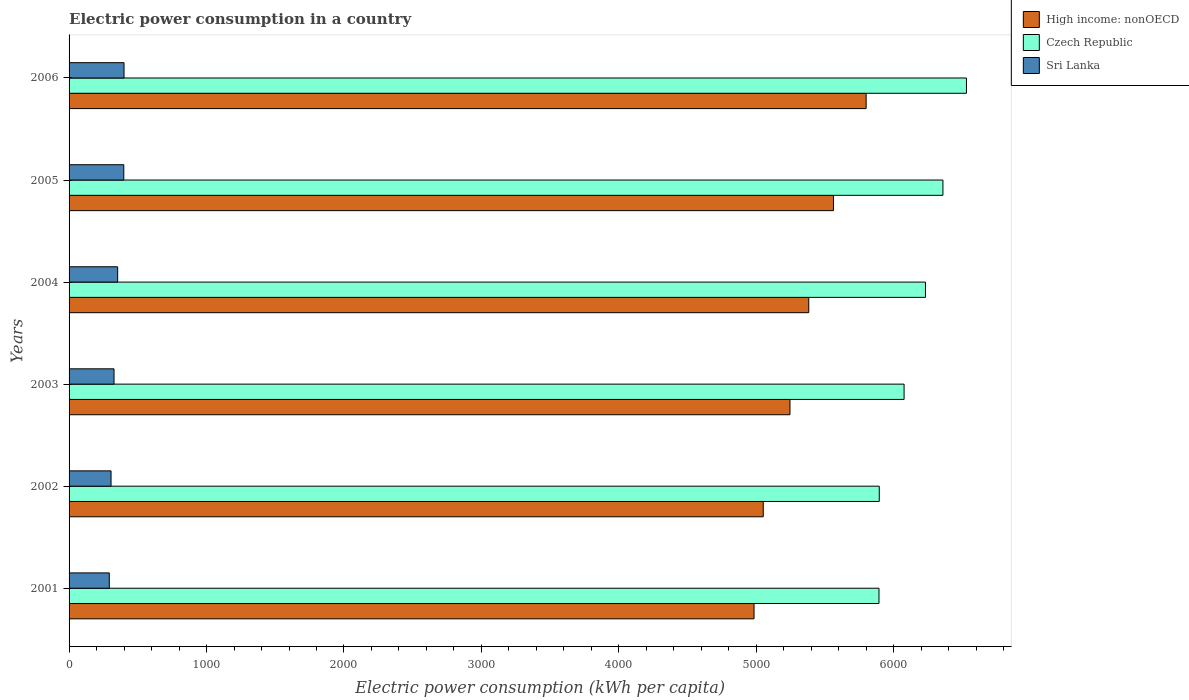How many different coloured bars are there?
Make the answer very short. 3. Are the number of bars per tick equal to the number of legend labels?
Your answer should be compact. Yes. Are the number of bars on each tick of the Y-axis equal?
Give a very brief answer. Yes. How many bars are there on the 5th tick from the bottom?
Your response must be concise. 3. In how many cases, is the number of bars for a given year not equal to the number of legend labels?
Your answer should be very brief. 0. What is the electric power consumption in in Sri Lanka in 2001?
Keep it short and to the point. 292.6. Across all years, what is the maximum electric power consumption in in High income: nonOECD?
Your answer should be compact. 5798.77. Across all years, what is the minimum electric power consumption in in High income: nonOECD?
Your answer should be very brief. 4983.16. In which year was the electric power consumption in in Sri Lanka maximum?
Your response must be concise. 2006. In which year was the electric power consumption in in Czech Republic minimum?
Offer a very short reply. 2001. What is the total electric power consumption in in Czech Republic in the graph?
Provide a short and direct response. 3.70e+04. What is the difference between the electric power consumption in in High income: nonOECD in 2001 and that in 2005?
Your response must be concise. -577.9. What is the difference between the electric power consumption in in Czech Republic in 2006 and the electric power consumption in in Sri Lanka in 2005?
Provide a short and direct response. 6130.44. What is the average electric power consumption in in High income: nonOECD per year?
Offer a very short reply. 5336.52. In the year 2002, what is the difference between the electric power consumption in in High income: nonOECD and electric power consumption in in Sri Lanka?
Make the answer very short. 4744.83. What is the ratio of the electric power consumption in in Czech Republic in 2003 to that in 2006?
Ensure brevity in your answer.  0.93. What is the difference between the highest and the second highest electric power consumption in in Sri Lanka?
Provide a succinct answer. 1.7. What is the difference between the highest and the lowest electric power consumption in in High income: nonOECD?
Provide a short and direct response. 815.62. What does the 1st bar from the top in 2002 represents?
Give a very brief answer. Sri Lanka. What does the 2nd bar from the bottom in 2005 represents?
Offer a very short reply. Czech Republic. Is it the case that in every year, the sum of the electric power consumption in in Sri Lanka and electric power consumption in in High income: nonOECD is greater than the electric power consumption in in Czech Republic?
Your response must be concise. No. How many bars are there?
Provide a short and direct response. 18. Does the graph contain grids?
Provide a short and direct response. No. What is the title of the graph?
Offer a terse response. Electric power consumption in a country. Does "Italy" appear as one of the legend labels in the graph?
Provide a short and direct response. No. What is the label or title of the X-axis?
Offer a terse response. Electric power consumption (kWh per capita). What is the Electric power consumption (kWh per capita) in High income: nonOECD in 2001?
Provide a succinct answer. 4983.16. What is the Electric power consumption (kWh per capita) of Czech Republic in 2001?
Your response must be concise. 5892.17. What is the Electric power consumption (kWh per capita) of Sri Lanka in 2001?
Offer a terse response. 292.6. What is the Electric power consumption (kWh per capita) in High income: nonOECD in 2002?
Give a very brief answer. 5050.21. What is the Electric power consumption (kWh per capita) in Czech Republic in 2002?
Your response must be concise. 5894.23. What is the Electric power consumption (kWh per capita) in Sri Lanka in 2002?
Your answer should be very brief. 305.37. What is the Electric power consumption (kWh per capita) in High income: nonOECD in 2003?
Offer a terse response. 5244.64. What is the Electric power consumption (kWh per capita) of Czech Republic in 2003?
Ensure brevity in your answer.  6074.85. What is the Electric power consumption (kWh per capita) of Sri Lanka in 2003?
Give a very brief answer. 327.13. What is the Electric power consumption (kWh per capita) of High income: nonOECD in 2004?
Keep it short and to the point. 5381.27. What is the Electric power consumption (kWh per capita) of Czech Republic in 2004?
Your response must be concise. 6230.4. What is the Electric power consumption (kWh per capita) of Sri Lanka in 2004?
Offer a terse response. 353.49. What is the Electric power consumption (kWh per capita) of High income: nonOECD in 2005?
Give a very brief answer. 5561.05. What is the Electric power consumption (kWh per capita) in Czech Republic in 2005?
Provide a succinct answer. 6357.42. What is the Electric power consumption (kWh per capita) of Sri Lanka in 2005?
Keep it short and to the point. 398.09. What is the Electric power consumption (kWh per capita) of High income: nonOECD in 2006?
Your answer should be very brief. 5798.77. What is the Electric power consumption (kWh per capita) of Czech Republic in 2006?
Your answer should be compact. 6528.53. What is the Electric power consumption (kWh per capita) in Sri Lanka in 2006?
Provide a succinct answer. 399.79. Across all years, what is the maximum Electric power consumption (kWh per capita) in High income: nonOECD?
Keep it short and to the point. 5798.77. Across all years, what is the maximum Electric power consumption (kWh per capita) of Czech Republic?
Your answer should be compact. 6528.53. Across all years, what is the maximum Electric power consumption (kWh per capita) of Sri Lanka?
Keep it short and to the point. 399.79. Across all years, what is the minimum Electric power consumption (kWh per capita) in High income: nonOECD?
Give a very brief answer. 4983.16. Across all years, what is the minimum Electric power consumption (kWh per capita) of Czech Republic?
Your answer should be compact. 5892.17. Across all years, what is the minimum Electric power consumption (kWh per capita) of Sri Lanka?
Your response must be concise. 292.6. What is the total Electric power consumption (kWh per capita) in High income: nonOECD in the graph?
Ensure brevity in your answer.  3.20e+04. What is the total Electric power consumption (kWh per capita) of Czech Republic in the graph?
Keep it short and to the point. 3.70e+04. What is the total Electric power consumption (kWh per capita) in Sri Lanka in the graph?
Offer a terse response. 2076.46. What is the difference between the Electric power consumption (kWh per capita) of High income: nonOECD in 2001 and that in 2002?
Provide a short and direct response. -67.05. What is the difference between the Electric power consumption (kWh per capita) of Czech Republic in 2001 and that in 2002?
Your answer should be very brief. -2.06. What is the difference between the Electric power consumption (kWh per capita) in Sri Lanka in 2001 and that in 2002?
Offer a terse response. -12.78. What is the difference between the Electric power consumption (kWh per capita) of High income: nonOECD in 2001 and that in 2003?
Your answer should be compact. -261.49. What is the difference between the Electric power consumption (kWh per capita) in Czech Republic in 2001 and that in 2003?
Offer a very short reply. -182.68. What is the difference between the Electric power consumption (kWh per capita) of Sri Lanka in 2001 and that in 2003?
Give a very brief answer. -34.53. What is the difference between the Electric power consumption (kWh per capita) in High income: nonOECD in 2001 and that in 2004?
Offer a terse response. -398.11. What is the difference between the Electric power consumption (kWh per capita) of Czech Republic in 2001 and that in 2004?
Keep it short and to the point. -338.23. What is the difference between the Electric power consumption (kWh per capita) in Sri Lanka in 2001 and that in 2004?
Provide a succinct answer. -60.89. What is the difference between the Electric power consumption (kWh per capita) in High income: nonOECD in 2001 and that in 2005?
Offer a very short reply. -577.9. What is the difference between the Electric power consumption (kWh per capita) in Czech Republic in 2001 and that in 2005?
Your answer should be very brief. -465.25. What is the difference between the Electric power consumption (kWh per capita) in Sri Lanka in 2001 and that in 2005?
Your response must be concise. -105.49. What is the difference between the Electric power consumption (kWh per capita) in High income: nonOECD in 2001 and that in 2006?
Give a very brief answer. -815.62. What is the difference between the Electric power consumption (kWh per capita) in Czech Republic in 2001 and that in 2006?
Your answer should be very brief. -636.36. What is the difference between the Electric power consumption (kWh per capita) in Sri Lanka in 2001 and that in 2006?
Your response must be concise. -107.19. What is the difference between the Electric power consumption (kWh per capita) in High income: nonOECD in 2002 and that in 2003?
Give a very brief answer. -194.44. What is the difference between the Electric power consumption (kWh per capita) of Czech Republic in 2002 and that in 2003?
Keep it short and to the point. -180.62. What is the difference between the Electric power consumption (kWh per capita) in Sri Lanka in 2002 and that in 2003?
Your answer should be compact. -21.75. What is the difference between the Electric power consumption (kWh per capita) of High income: nonOECD in 2002 and that in 2004?
Your response must be concise. -331.06. What is the difference between the Electric power consumption (kWh per capita) in Czech Republic in 2002 and that in 2004?
Your response must be concise. -336.17. What is the difference between the Electric power consumption (kWh per capita) in Sri Lanka in 2002 and that in 2004?
Your response must be concise. -48.11. What is the difference between the Electric power consumption (kWh per capita) in High income: nonOECD in 2002 and that in 2005?
Your answer should be very brief. -510.85. What is the difference between the Electric power consumption (kWh per capita) in Czech Republic in 2002 and that in 2005?
Offer a terse response. -463.19. What is the difference between the Electric power consumption (kWh per capita) of Sri Lanka in 2002 and that in 2005?
Your answer should be compact. -92.71. What is the difference between the Electric power consumption (kWh per capita) of High income: nonOECD in 2002 and that in 2006?
Offer a very short reply. -748.57. What is the difference between the Electric power consumption (kWh per capita) of Czech Republic in 2002 and that in 2006?
Your response must be concise. -634.3. What is the difference between the Electric power consumption (kWh per capita) of Sri Lanka in 2002 and that in 2006?
Make the answer very short. -94.41. What is the difference between the Electric power consumption (kWh per capita) in High income: nonOECD in 2003 and that in 2004?
Your response must be concise. -136.63. What is the difference between the Electric power consumption (kWh per capita) of Czech Republic in 2003 and that in 2004?
Ensure brevity in your answer.  -155.55. What is the difference between the Electric power consumption (kWh per capita) in Sri Lanka in 2003 and that in 2004?
Provide a succinct answer. -26.36. What is the difference between the Electric power consumption (kWh per capita) of High income: nonOECD in 2003 and that in 2005?
Your response must be concise. -316.41. What is the difference between the Electric power consumption (kWh per capita) in Czech Republic in 2003 and that in 2005?
Your answer should be compact. -282.57. What is the difference between the Electric power consumption (kWh per capita) of Sri Lanka in 2003 and that in 2005?
Give a very brief answer. -70.96. What is the difference between the Electric power consumption (kWh per capita) in High income: nonOECD in 2003 and that in 2006?
Ensure brevity in your answer.  -554.13. What is the difference between the Electric power consumption (kWh per capita) of Czech Republic in 2003 and that in 2006?
Your response must be concise. -453.68. What is the difference between the Electric power consumption (kWh per capita) of Sri Lanka in 2003 and that in 2006?
Give a very brief answer. -72.66. What is the difference between the Electric power consumption (kWh per capita) in High income: nonOECD in 2004 and that in 2005?
Give a very brief answer. -179.78. What is the difference between the Electric power consumption (kWh per capita) in Czech Republic in 2004 and that in 2005?
Ensure brevity in your answer.  -127.02. What is the difference between the Electric power consumption (kWh per capita) of Sri Lanka in 2004 and that in 2005?
Offer a terse response. -44.6. What is the difference between the Electric power consumption (kWh per capita) in High income: nonOECD in 2004 and that in 2006?
Provide a succinct answer. -417.5. What is the difference between the Electric power consumption (kWh per capita) in Czech Republic in 2004 and that in 2006?
Offer a very short reply. -298.13. What is the difference between the Electric power consumption (kWh per capita) in Sri Lanka in 2004 and that in 2006?
Keep it short and to the point. -46.3. What is the difference between the Electric power consumption (kWh per capita) of High income: nonOECD in 2005 and that in 2006?
Provide a short and direct response. -237.72. What is the difference between the Electric power consumption (kWh per capita) in Czech Republic in 2005 and that in 2006?
Your response must be concise. -171.11. What is the difference between the Electric power consumption (kWh per capita) of Sri Lanka in 2005 and that in 2006?
Make the answer very short. -1.7. What is the difference between the Electric power consumption (kWh per capita) of High income: nonOECD in 2001 and the Electric power consumption (kWh per capita) of Czech Republic in 2002?
Your answer should be compact. -911.08. What is the difference between the Electric power consumption (kWh per capita) in High income: nonOECD in 2001 and the Electric power consumption (kWh per capita) in Sri Lanka in 2002?
Ensure brevity in your answer.  4677.78. What is the difference between the Electric power consumption (kWh per capita) of Czech Republic in 2001 and the Electric power consumption (kWh per capita) of Sri Lanka in 2002?
Provide a succinct answer. 5586.8. What is the difference between the Electric power consumption (kWh per capita) of High income: nonOECD in 2001 and the Electric power consumption (kWh per capita) of Czech Republic in 2003?
Provide a succinct answer. -1091.69. What is the difference between the Electric power consumption (kWh per capita) of High income: nonOECD in 2001 and the Electric power consumption (kWh per capita) of Sri Lanka in 2003?
Your answer should be compact. 4656.03. What is the difference between the Electric power consumption (kWh per capita) in Czech Republic in 2001 and the Electric power consumption (kWh per capita) in Sri Lanka in 2003?
Ensure brevity in your answer.  5565.05. What is the difference between the Electric power consumption (kWh per capita) of High income: nonOECD in 2001 and the Electric power consumption (kWh per capita) of Czech Republic in 2004?
Give a very brief answer. -1247.24. What is the difference between the Electric power consumption (kWh per capita) of High income: nonOECD in 2001 and the Electric power consumption (kWh per capita) of Sri Lanka in 2004?
Your answer should be compact. 4629.67. What is the difference between the Electric power consumption (kWh per capita) in Czech Republic in 2001 and the Electric power consumption (kWh per capita) in Sri Lanka in 2004?
Provide a short and direct response. 5538.69. What is the difference between the Electric power consumption (kWh per capita) in High income: nonOECD in 2001 and the Electric power consumption (kWh per capita) in Czech Republic in 2005?
Offer a terse response. -1374.27. What is the difference between the Electric power consumption (kWh per capita) of High income: nonOECD in 2001 and the Electric power consumption (kWh per capita) of Sri Lanka in 2005?
Offer a very short reply. 4585.07. What is the difference between the Electric power consumption (kWh per capita) of Czech Republic in 2001 and the Electric power consumption (kWh per capita) of Sri Lanka in 2005?
Ensure brevity in your answer.  5494.09. What is the difference between the Electric power consumption (kWh per capita) of High income: nonOECD in 2001 and the Electric power consumption (kWh per capita) of Czech Republic in 2006?
Make the answer very short. -1545.37. What is the difference between the Electric power consumption (kWh per capita) of High income: nonOECD in 2001 and the Electric power consumption (kWh per capita) of Sri Lanka in 2006?
Your response must be concise. 4583.37. What is the difference between the Electric power consumption (kWh per capita) of Czech Republic in 2001 and the Electric power consumption (kWh per capita) of Sri Lanka in 2006?
Ensure brevity in your answer.  5492.38. What is the difference between the Electric power consumption (kWh per capita) in High income: nonOECD in 2002 and the Electric power consumption (kWh per capita) in Czech Republic in 2003?
Ensure brevity in your answer.  -1024.64. What is the difference between the Electric power consumption (kWh per capita) of High income: nonOECD in 2002 and the Electric power consumption (kWh per capita) of Sri Lanka in 2003?
Ensure brevity in your answer.  4723.08. What is the difference between the Electric power consumption (kWh per capita) of Czech Republic in 2002 and the Electric power consumption (kWh per capita) of Sri Lanka in 2003?
Keep it short and to the point. 5567.11. What is the difference between the Electric power consumption (kWh per capita) in High income: nonOECD in 2002 and the Electric power consumption (kWh per capita) in Czech Republic in 2004?
Make the answer very short. -1180.19. What is the difference between the Electric power consumption (kWh per capita) of High income: nonOECD in 2002 and the Electric power consumption (kWh per capita) of Sri Lanka in 2004?
Ensure brevity in your answer.  4696.72. What is the difference between the Electric power consumption (kWh per capita) in Czech Republic in 2002 and the Electric power consumption (kWh per capita) in Sri Lanka in 2004?
Ensure brevity in your answer.  5540.75. What is the difference between the Electric power consumption (kWh per capita) of High income: nonOECD in 2002 and the Electric power consumption (kWh per capita) of Czech Republic in 2005?
Ensure brevity in your answer.  -1307.21. What is the difference between the Electric power consumption (kWh per capita) of High income: nonOECD in 2002 and the Electric power consumption (kWh per capita) of Sri Lanka in 2005?
Your response must be concise. 4652.12. What is the difference between the Electric power consumption (kWh per capita) in Czech Republic in 2002 and the Electric power consumption (kWh per capita) in Sri Lanka in 2005?
Your response must be concise. 5496.15. What is the difference between the Electric power consumption (kWh per capita) in High income: nonOECD in 2002 and the Electric power consumption (kWh per capita) in Czech Republic in 2006?
Provide a succinct answer. -1478.32. What is the difference between the Electric power consumption (kWh per capita) of High income: nonOECD in 2002 and the Electric power consumption (kWh per capita) of Sri Lanka in 2006?
Your response must be concise. 4650.42. What is the difference between the Electric power consumption (kWh per capita) in Czech Republic in 2002 and the Electric power consumption (kWh per capita) in Sri Lanka in 2006?
Your answer should be compact. 5494.44. What is the difference between the Electric power consumption (kWh per capita) in High income: nonOECD in 2003 and the Electric power consumption (kWh per capita) in Czech Republic in 2004?
Provide a short and direct response. -985.76. What is the difference between the Electric power consumption (kWh per capita) of High income: nonOECD in 2003 and the Electric power consumption (kWh per capita) of Sri Lanka in 2004?
Ensure brevity in your answer.  4891.16. What is the difference between the Electric power consumption (kWh per capita) in Czech Republic in 2003 and the Electric power consumption (kWh per capita) in Sri Lanka in 2004?
Keep it short and to the point. 5721.36. What is the difference between the Electric power consumption (kWh per capita) of High income: nonOECD in 2003 and the Electric power consumption (kWh per capita) of Czech Republic in 2005?
Offer a terse response. -1112.78. What is the difference between the Electric power consumption (kWh per capita) of High income: nonOECD in 2003 and the Electric power consumption (kWh per capita) of Sri Lanka in 2005?
Keep it short and to the point. 4846.56. What is the difference between the Electric power consumption (kWh per capita) of Czech Republic in 2003 and the Electric power consumption (kWh per capita) of Sri Lanka in 2005?
Provide a succinct answer. 5676.76. What is the difference between the Electric power consumption (kWh per capita) of High income: nonOECD in 2003 and the Electric power consumption (kWh per capita) of Czech Republic in 2006?
Make the answer very short. -1283.89. What is the difference between the Electric power consumption (kWh per capita) in High income: nonOECD in 2003 and the Electric power consumption (kWh per capita) in Sri Lanka in 2006?
Your answer should be compact. 4844.85. What is the difference between the Electric power consumption (kWh per capita) of Czech Republic in 2003 and the Electric power consumption (kWh per capita) of Sri Lanka in 2006?
Make the answer very short. 5675.06. What is the difference between the Electric power consumption (kWh per capita) of High income: nonOECD in 2004 and the Electric power consumption (kWh per capita) of Czech Republic in 2005?
Your answer should be very brief. -976.15. What is the difference between the Electric power consumption (kWh per capita) of High income: nonOECD in 2004 and the Electric power consumption (kWh per capita) of Sri Lanka in 2005?
Make the answer very short. 4983.18. What is the difference between the Electric power consumption (kWh per capita) of Czech Republic in 2004 and the Electric power consumption (kWh per capita) of Sri Lanka in 2005?
Offer a very short reply. 5832.31. What is the difference between the Electric power consumption (kWh per capita) in High income: nonOECD in 2004 and the Electric power consumption (kWh per capita) in Czech Republic in 2006?
Offer a terse response. -1147.26. What is the difference between the Electric power consumption (kWh per capita) in High income: nonOECD in 2004 and the Electric power consumption (kWh per capita) in Sri Lanka in 2006?
Make the answer very short. 4981.48. What is the difference between the Electric power consumption (kWh per capita) in Czech Republic in 2004 and the Electric power consumption (kWh per capita) in Sri Lanka in 2006?
Your response must be concise. 5830.61. What is the difference between the Electric power consumption (kWh per capita) of High income: nonOECD in 2005 and the Electric power consumption (kWh per capita) of Czech Republic in 2006?
Make the answer very short. -967.48. What is the difference between the Electric power consumption (kWh per capita) of High income: nonOECD in 2005 and the Electric power consumption (kWh per capita) of Sri Lanka in 2006?
Your answer should be compact. 5161.27. What is the difference between the Electric power consumption (kWh per capita) of Czech Republic in 2005 and the Electric power consumption (kWh per capita) of Sri Lanka in 2006?
Give a very brief answer. 5957.63. What is the average Electric power consumption (kWh per capita) in High income: nonOECD per year?
Your answer should be very brief. 5336.52. What is the average Electric power consumption (kWh per capita) in Czech Republic per year?
Make the answer very short. 6162.93. What is the average Electric power consumption (kWh per capita) in Sri Lanka per year?
Your answer should be compact. 346.08. In the year 2001, what is the difference between the Electric power consumption (kWh per capita) of High income: nonOECD and Electric power consumption (kWh per capita) of Czech Republic?
Ensure brevity in your answer.  -909.02. In the year 2001, what is the difference between the Electric power consumption (kWh per capita) in High income: nonOECD and Electric power consumption (kWh per capita) in Sri Lanka?
Offer a very short reply. 4690.56. In the year 2001, what is the difference between the Electric power consumption (kWh per capita) of Czech Republic and Electric power consumption (kWh per capita) of Sri Lanka?
Provide a succinct answer. 5599.57. In the year 2002, what is the difference between the Electric power consumption (kWh per capita) in High income: nonOECD and Electric power consumption (kWh per capita) in Czech Republic?
Provide a short and direct response. -844.03. In the year 2002, what is the difference between the Electric power consumption (kWh per capita) in High income: nonOECD and Electric power consumption (kWh per capita) in Sri Lanka?
Make the answer very short. 4744.83. In the year 2002, what is the difference between the Electric power consumption (kWh per capita) in Czech Republic and Electric power consumption (kWh per capita) in Sri Lanka?
Keep it short and to the point. 5588.86. In the year 2003, what is the difference between the Electric power consumption (kWh per capita) in High income: nonOECD and Electric power consumption (kWh per capita) in Czech Republic?
Offer a very short reply. -830.21. In the year 2003, what is the difference between the Electric power consumption (kWh per capita) in High income: nonOECD and Electric power consumption (kWh per capita) in Sri Lanka?
Ensure brevity in your answer.  4917.52. In the year 2003, what is the difference between the Electric power consumption (kWh per capita) in Czech Republic and Electric power consumption (kWh per capita) in Sri Lanka?
Your response must be concise. 5747.72. In the year 2004, what is the difference between the Electric power consumption (kWh per capita) in High income: nonOECD and Electric power consumption (kWh per capita) in Czech Republic?
Your response must be concise. -849.13. In the year 2004, what is the difference between the Electric power consumption (kWh per capita) in High income: nonOECD and Electric power consumption (kWh per capita) in Sri Lanka?
Make the answer very short. 5027.78. In the year 2004, what is the difference between the Electric power consumption (kWh per capita) in Czech Republic and Electric power consumption (kWh per capita) in Sri Lanka?
Your response must be concise. 5876.91. In the year 2005, what is the difference between the Electric power consumption (kWh per capita) in High income: nonOECD and Electric power consumption (kWh per capita) in Czech Republic?
Make the answer very short. -796.37. In the year 2005, what is the difference between the Electric power consumption (kWh per capita) in High income: nonOECD and Electric power consumption (kWh per capita) in Sri Lanka?
Provide a short and direct response. 5162.97. In the year 2005, what is the difference between the Electric power consumption (kWh per capita) of Czech Republic and Electric power consumption (kWh per capita) of Sri Lanka?
Your answer should be very brief. 5959.34. In the year 2006, what is the difference between the Electric power consumption (kWh per capita) in High income: nonOECD and Electric power consumption (kWh per capita) in Czech Republic?
Provide a succinct answer. -729.76. In the year 2006, what is the difference between the Electric power consumption (kWh per capita) of High income: nonOECD and Electric power consumption (kWh per capita) of Sri Lanka?
Keep it short and to the point. 5398.98. In the year 2006, what is the difference between the Electric power consumption (kWh per capita) of Czech Republic and Electric power consumption (kWh per capita) of Sri Lanka?
Ensure brevity in your answer.  6128.74. What is the ratio of the Electric power consumption (kWh per capita) in High income: nonOECD in 2001 to that in 2002?
Offer a terse response. 0.99. What is the ratio of the Electric power consumption (kWh per capita) in Czech Republic in 2001 to that in 2002?
Give a very brief answer. 1. What is the ratio of the Electric power consumption (kWh per capita) in Sri Lanka in 2001 to that in 2002?
Ensure brevity in your answer.  0.96. What is the ratio of the Electric power consumption (kWh per capita) in High income: nonOECD in 2001 to that in 2003?
Provide a short and direct response. 0.95. What is the ratio of the Electric power consumption (kWh per capita) in Czech Republic in 2001 to that in 2003?
Your answer should be compact. 0.97. What is the ratio of the Electric power consumption (kWh per capita) of Sri Lanka in 2001 to that in 2003?
Give a very brief answer. 0.89. What is the ratio of the Electric power consumption (kWh per capita) of High income: nonOECD in 2001 to that in 2004?
Your answer should be compact. 0.93. What is the ratio of the Electric power consumption (kWh per capita) of Czech Republic in 2001 to that in 2004?
Your answer should be very brief. 0.95. What is the ratio of the Electric power consumption (kWh per capita) in Sri Lanka in 2001 to that in 2004?
Offer a terse response. 0.83. What is the ratio of the Electric power consumption (kWh per capita) in High income: nonOECD in 2001 to that in 2005?
Provide a short and direct response. 0.9. What is the ratio of the Electric power consumption (kWh per capita) in Czech Republic in 2001 to that in 2005?
Your response must be concise. 0.93. What is the ratio of the Electric power consumption (kWh per capita) of Sri Lanka in 2001 to that in 2005?
Your response must be concise. 0.73. What is the ratio of the Electric power consumption (kWh per capita) of High income: nonOECD in 2001 to that in 2006?
Keep it short and to the point. 0.86. What is the ratio of the Electric power consumption (kWh per capita) in Czech Republic in 2001 to that in 2006?
Your answer should be compact. 0.9. What is the ratio of the Electric power consumption (kWh per capita) of Sri Lanka in 2001 to that in 2006?
Provide a short and direct response. 0.73. What is the ratio of the Electric power consumption (kWh per capita) of High income: nonOECD in 2002 to that in 2003?
Your response must be concise. 0.96. What is the ratio of the Electric power consumption (kWh per capita) in Czech Republic in 2002 to that in 2003?
Give a very brief answer. 0.97. What is the ratio of the Electric power consumption (kWh per capita) in Sri Lanka in 2002 to that in 2003?
Give a very brief answer. 0.93. What is the ratio of the Electric power consumption (kWh per capita) in High income: nonOECD in 2002 to that in 2004?
Make the answer very short. 0.94. What is the ratio of the Electric power consumption (kWh per capita) of Czech Republic in 2002 to that in 2004?
Provide a succinct answer. 0.95. What is the ratio of the Electric power consumption (kWh per capita) of Sri Lanka in 2002 to that in 2004?
Give a very brief answer. 0.86. What is the ratio of the Electric power consumption (kWh per capita) in High income: nonOECD in 2002 to that in 2005?
Provide a short and direct response. 0.91. What is the ratio of the Electric power consumption (kWh per capita) of Czech Republic in 2002 to that in 2005?
Make the answer very short. 0.93. What is the ratio of the Electric power consumption (kWh per capita) in Sri Lanka in 2002 to that in 2005?
Keep it short and to the point. 0.77. What is the ratio of the Electric power consumption (kWh per capita) of High income: nonOECD in 2002 to that in 2006?
Ensure brevity in your answer.  0.87. What is the ratio of the Electric power consumption (kWh per capita) of Czech Republic in 2002 to that in 2006?
Your response must be concise. 0.9. What is the ratio of the Electric power consumption (kWh per capita) of Sri Lanka in 2002 to that in 2006?
Give a very brief answer. 0.76. What is the ratio of the Electric power consumption (kWh per capita) of High income: nonOECD in 2003 to that in 2004?
Ensure brevity in your answer.  0.97. What is the ratio of the Electric power consumption (kWh per capita) of Czech Republic in 2003 to that in 2004?
Your response must be concise. 0.97. What is the ratio of the Electric power consumption (kWh per capita) of Sri Lanka in 2003 to that in 2004?
Provide a short and direct response. 0.93. What is the ratio of the Electric power consumption (kWh per capita) in High income: nonOECD in 2003 to that in 2005?
Provide a short and direct response. 0.94. What is the ratio of the Electric power consumption (kWh per capita) of Czech Republic in 2003 to that in 2005?
Make the answer very short. 0.96. What is the ratio of the Electric power consumption (kWh per capita) of Sri Lanka in 2003 to that in 2005?
Ensure brevity in your answer.  0.82. What is the ratio of the Electric power consumption (kWh per capita) in High income: nonOECD in 2003 to that in 2006?
Your answer should be compact. 0.9. What is the ratio of the Electric power consumption (kWh per capita) in Czech Republic in 2003 to that in 2006?
Make the answer very short. 0.93. What is the ratio of the Electric power consumption (kWh per capita) in Sri Lanka in 2003 to that in 2006?
Offer a terse response. 0.82. What is the ratio of the Electric power consumption (kWh per capita) in High income: nonOECD in 2004 to that in 2005?
Provide a succinct answer. 0.97. What is the ratio of the Electric power consumption (kWh per capita) in Czech Republic in 2004 to that in 2005?
Make the answer very short. 0.98. What is the ratio of the Electric power consumption (kWh per capita) of Sri Lanka in 2004 to that in 2005?
Keep it short and to the point. 0.89. What is the ratio of the Electric power consumption (kWh per capita) in High income: nonOECD in 2004 to that in 2006?
Ensure brevity in your answer.  0.93. What is the ratio of the Electric power consumption (kWh per capita) in Czech Republic in 2004 to that in 2006?
Your response must be concise. 0.95. What is the ratio of the Electric power consumption (kWh per capita) of Sri Lanka in 2004 to that in 2006?
Give a very brief answer. 0.88. What is the ratio of the Electric power consumption (kWh per capita) in Czech Republic in 2005 to that in 2006?
Offer a very short reply. 0.97. What is the ratio of the Electric power consumption (kWh per capita) in Sri Lanka in 2005 to that in 2006?
Make the answer very short. 1. What is the difference between the highest and the second highest Electric power consumption (kWh per capita) in High income: nonOECD?
Provide a short and direct response. 237.72. What is the difference between the highest and the second highest Electric power consumption (kWh per capita) of Czech Republic?
Offer a very short reply. 171.11. What is the difference between the highest and the second highest Electric power consumption (kWh per capita) in Sri Lanka?
Ensure brevity in your answer.  1.7. What is the difference between the highest and the lowest Electric power consumption (kWh per capita) of High income: nonOECD?
Offer a very short reply. 815.62. What is the difference between the highest and the lowest Electric power consumption (kWh per capita) of Czech Republic?
Provide a short and direct response. 636.36. What is the difference between the highest and the lowest Electric power consumption (kWh per capita) of Sri Lanka?
Make the answer very short. 107.19. 